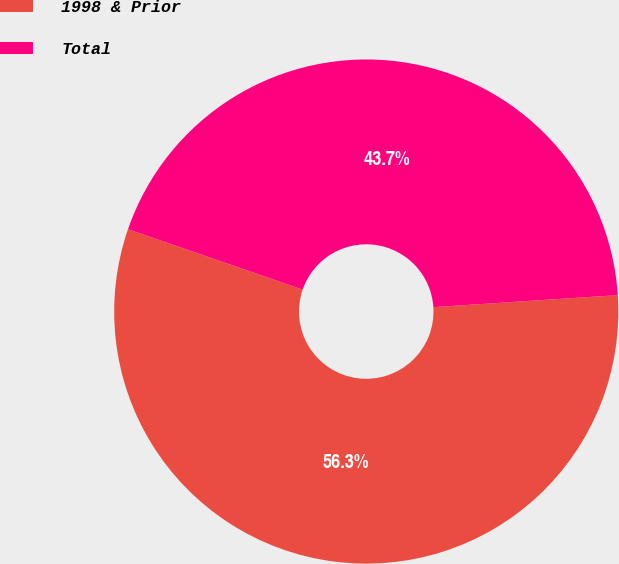Convert chart. <chart><loc_0><loc_0><loc_500><loc_500><pie_chart><fcel>1998 & Prior<fcel>Total<nl><fcel>56.33%<fcel>43.67%<nl></chart> 